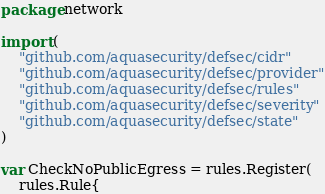<code> <loc_0><loc_0><loc_500><loc_500><_Go_>package network

import (
	"github.com/aquasecurity/defsec/cidr"
	"github.com/aquasecurity/defsec/provider"
	"github.com/aquasecurity/defsec/rules"
	"github.com/aquasecurity/defsec/severity"
	"github.com/aquasecurity/defsec/state"
)

var CheckNoPublicEgress = rules.Register(
	rules.Rule{</code> 